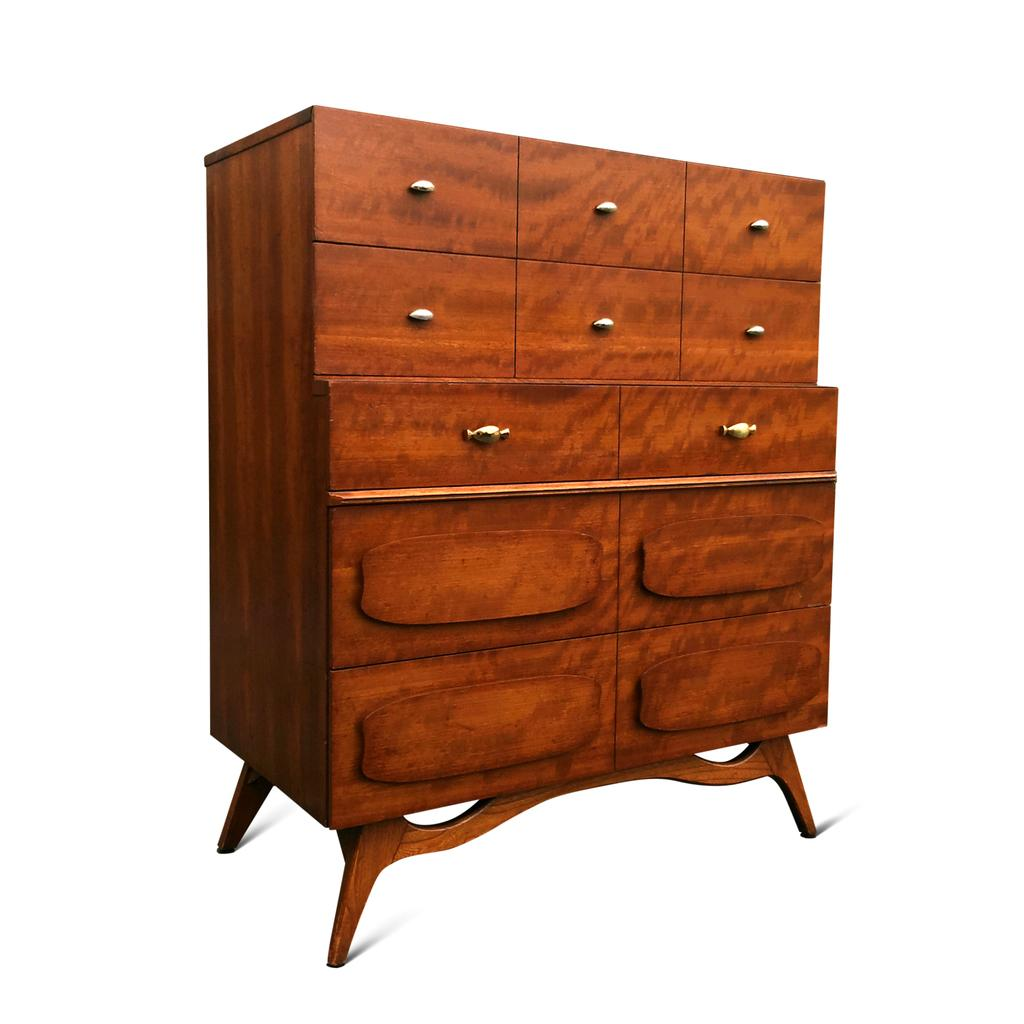What type of furniture is present in the image? There is a chest of drawers in the image. What color is the background of the image? The background of the image is white. What type of skirt is hanging in the hall in the image? There is no skirt or hall present in the image; it only features a chest of drawers against a white background. 